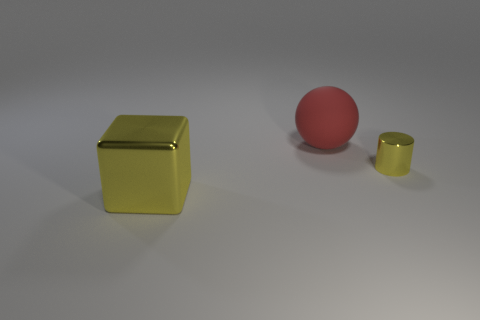Add 1 yellow cylinders. How many objects exist? 4 Subtract all spheres. How many objects are left? 2 Add 1 large purple matte cylinders. How many large purple matte cylinders exist? 1 Subtract 0 yellow spheres. How many objects are left? 3 Subtract all large green matte cylinders. Subtract all big yellow things. How many objects are left? 2 Add 2 rubber things. How many rubber things are left? 3 